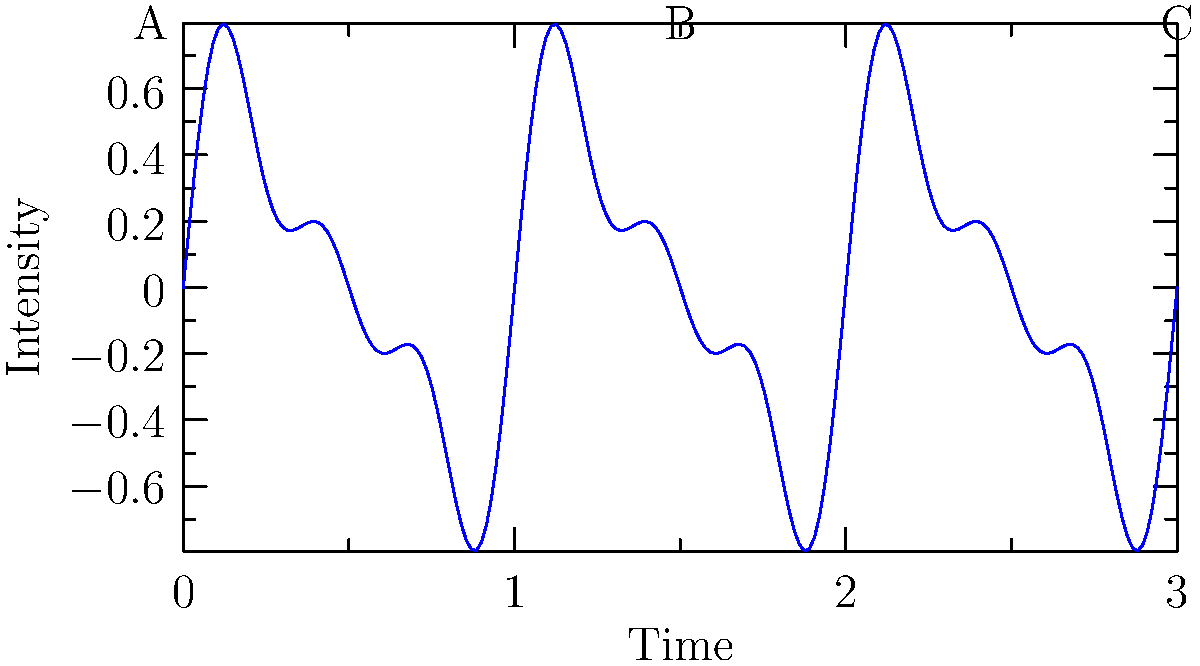The waveform graph above represents the rhythm and pacing of a prose passage. Analyze the graph and explain how it might correspond to the narrative structure. Which section (A, B, or C) likely represents the climax of the story, and why? To analyze this waveform graph in relation to narrative structure:

1. Interpret the axes:
   - X-axis represents time or progression through the text
   - Y-axis represents intensity or emotional impact

2. Observe the overall pattern:
   - The wave shows a combination of different frequencies
   - This suggests a complex narrative with varying pacing

3. Analyze each section:
   A: Shows lower amplitude and frequency, indicating a slower, more measured pace
   B: Displays increasing amplitude and frequency, suggesting rising tension and faster pacing
   C: Exhibits the highest amplitude and frequency, implying the most intense and rapid part of the narrative

4. Relate to narrative structure:
   A: Likely represents the exposition or rising action
   B: Probably depicts the building tension leading to the climax
   C: Most likely represents the climax of the story

5. Justify the climax (C):
   - Highest amplitude indicates peak emotional intensity
   - Increased frequency suggests rapid plot developments
   - Position at the end of the graph aligns with typical narrative structure

6. Consider the implications for prose:
   - Shorter sentences and paragraphs in section C
   - More descriptive, slower-paced writing in section A
   - Gradual increase in pacing and intensity through section B

This analysis demonstrates how waveform graphs can visually represent the rhythm and pacing of prose, offering writers a unique tool for structuring and refining their narratives.
Answer: C, due to highest amplitude and frequency, indicating peak emotional intensity and rapid plot developments. 